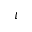Convert formula to latex. <formula><loc_0><loc_0><loc_500><loc_500>\iota</formula> 